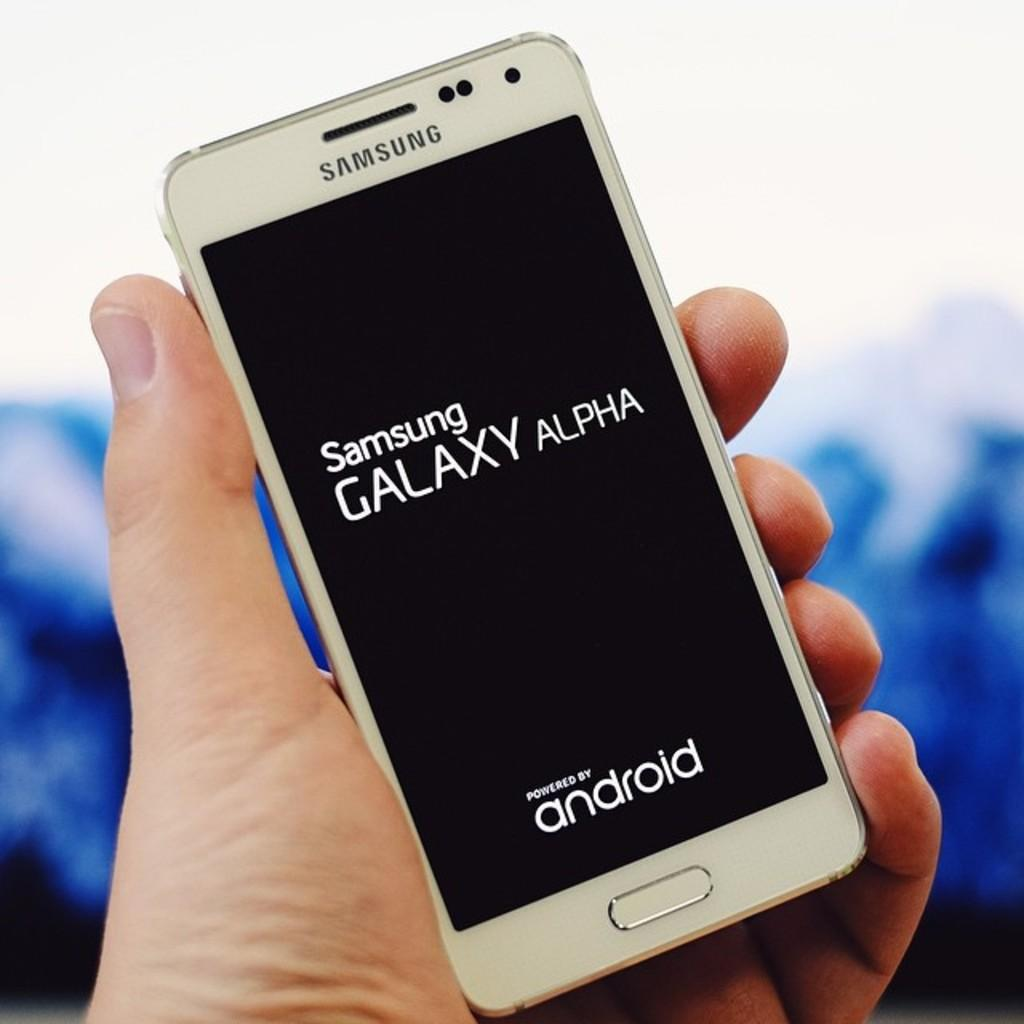Provide a one-sentence caption for the provided image. samsung galaxy alpha phone by android a man is holding it. 